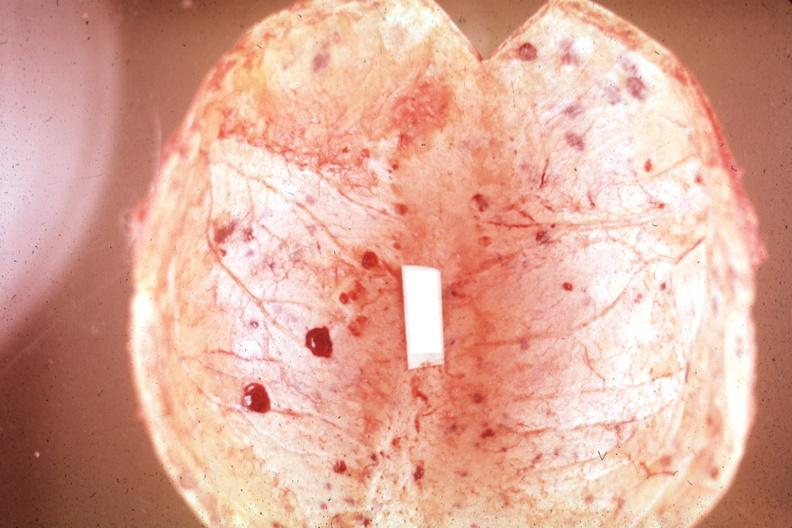what is present?
Answer the question using a single word or phrase. Joints 